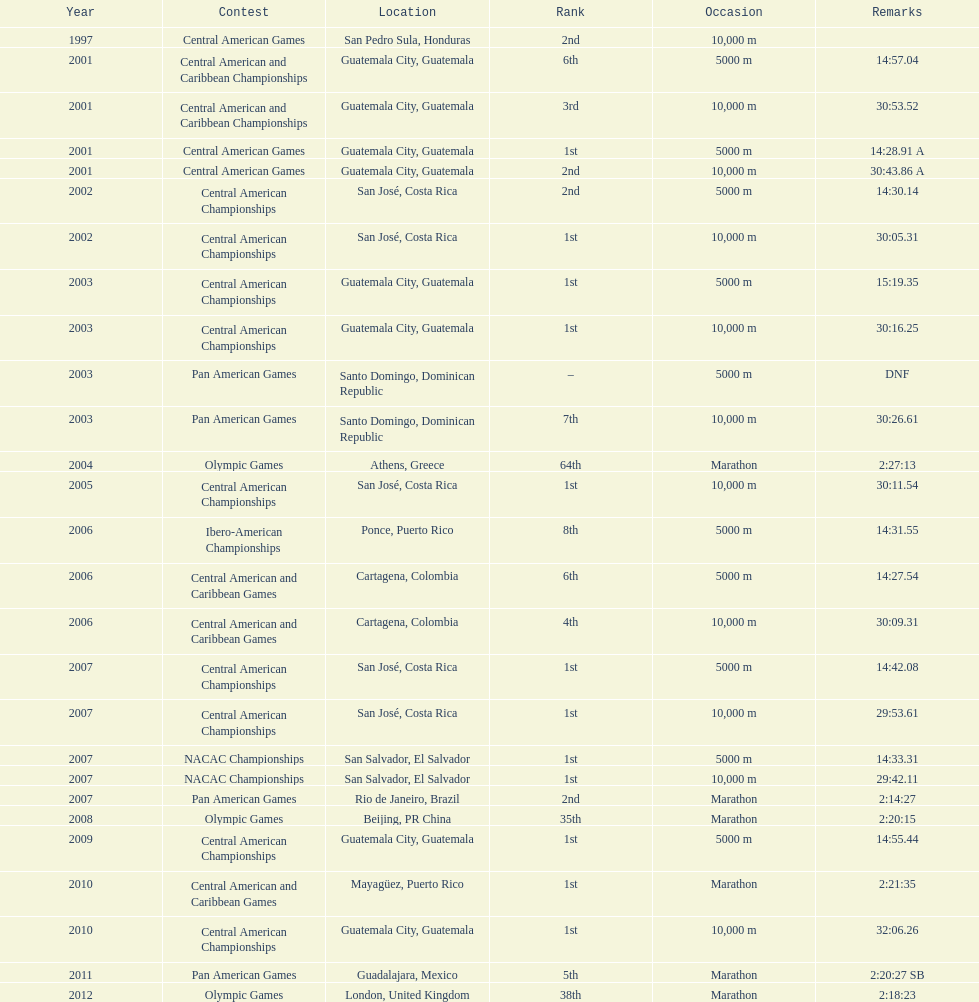What was the first competition this competitor competed in? Central American Games. 